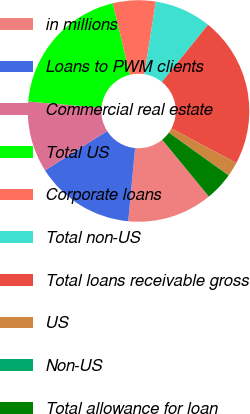Convert chart to OTSL. <chart><loc_0><loc_0><loc_500><loc_500><pie_chart><fcel>in millions<fcel>Loans to PWM clients<fcel>Commercial real estate<fcel>Total US<fcel>Corporate loans<fcel>Total non-US<fcel>Total loans receivable gross<fcel>US<fcel>Non-US<fcel>Total allowance for loan<nl><fcel>12.44%<fcel>14.51%<fcel>10.37%<fcel>19.91%<fcel>6.23%<fcel>8.3%<fcel>21.98%<fcel>2.09%<fcel>0.02%<fcel>4.16%<nl></chart> 